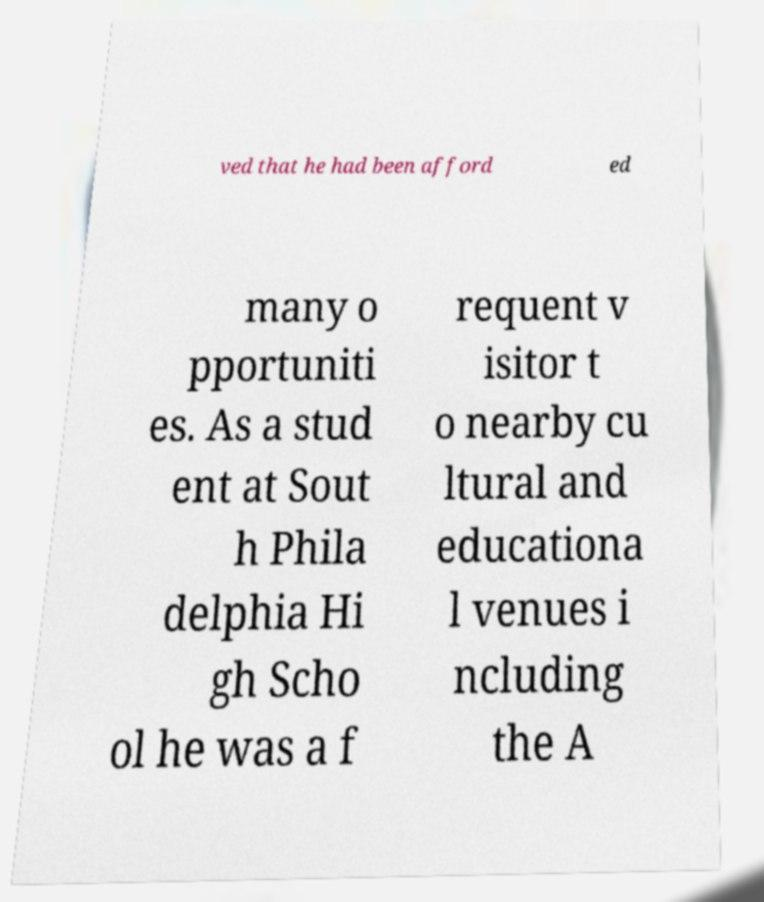There's text embedded in this image that I need extracted. Can you transcribe it verbatim? ved that he had been afford ed many o pportuniti es. As a stud ent at Sout h Phila delphia Hi gh Scho ol he was a f requent v isitor t o nearby cu ltural and educationa l venues i ncluding the A 